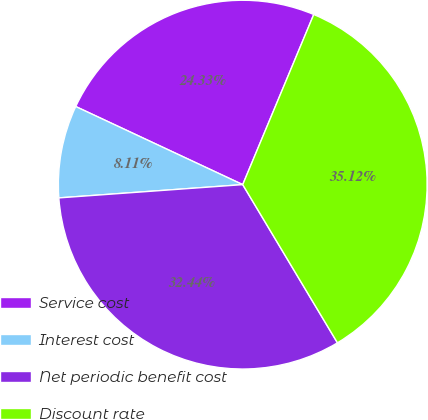Convert chart to OTSL. <chart><loc_0><loc_0><loc_500><loc_500><pie_chart><fcel>Service cost<fcel>Interest cost<fcel>Net periodic benefit cost<fcel>Discount rate<nl><fcel>24.33%<fcel>8.11%<fcel>32.44%<fcel>35.12%<nl></chart> 